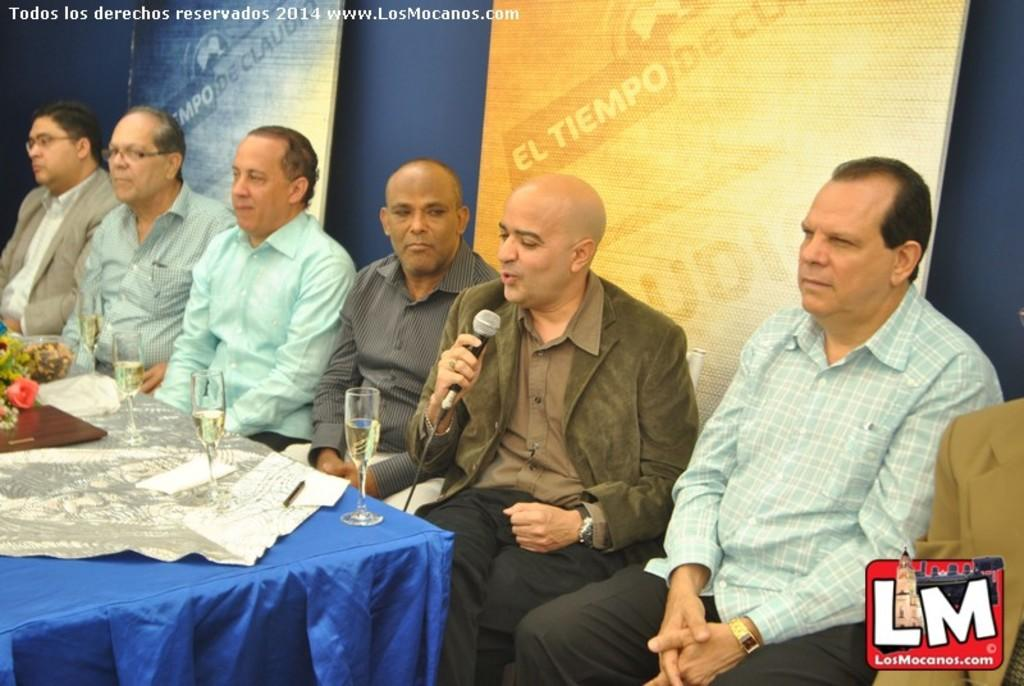How many people are present in the image? There are six people in the image. What are the people doing in the image? The people are sitting on chairs. What is the main piece of furniture in the image? There is a table in the image. What can be seen on the table? There are glasses on the table, as well as other items. What type of paste is being used by the people in the image? There is no paste present in the image; the people are simply sitting on chairs. Can you tell me what day of the week it is in the image? The image does not provide any information about the day of the week. 